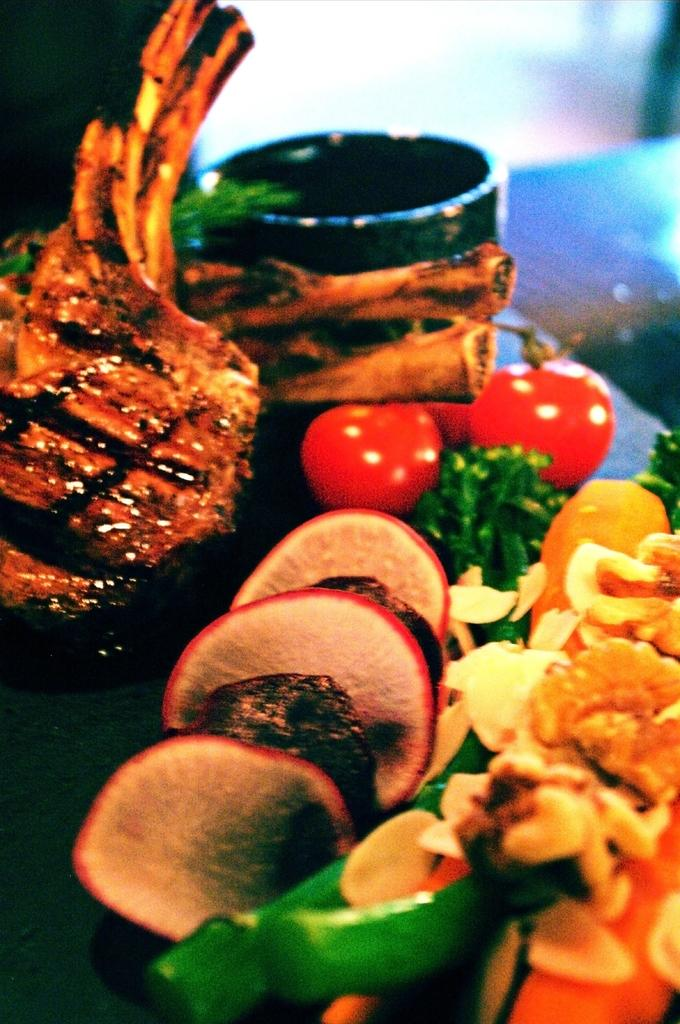What types of food items can be seen in the image? There are food items in the image, with various colors including brown, black, red, green, cream, and orange. What color is the bowl that contains some of the food items? The bowl is black-colored. Can you describe the background of the image? The background of the image is blurry. How many girls are drawing with chalk on the sidewalk in the image? There are no girls or sidewalks present in the image; it features food items and a bowl. 